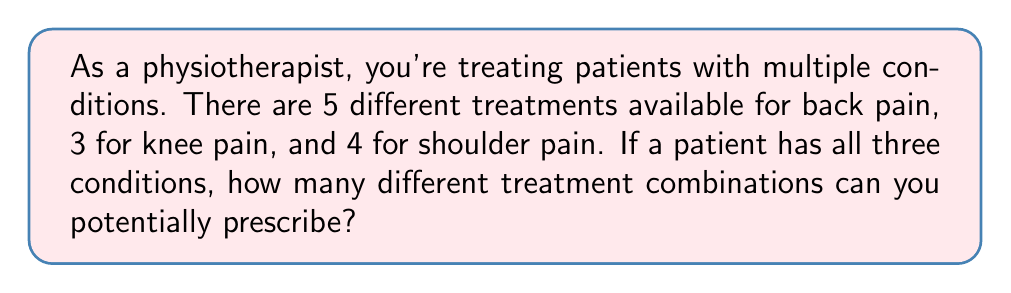Give your solution to this math problem. Let's approach this step-by-step:

1) We have three independent conditions, each with its own set of treatment options:
   - Back pain: 5 options
   - Knee pain: 3 options
   - Shoulder pain: 4 options

2) For each condition, we need to choose one treatment option. The choices for each condition are independent of the others.

3) This scenario is a perfect application of the multiplication principle in combinatorics. When we have independent events, and we want to know the total number of ways all events can occur, we multiply the number of ways each event can occur.

4) Mathematically, we can express this as:

   $$ \text{Total combinations} = \text{Back options} \times \text{Knee options} \times \text{Shoulder options} $$

5) Substituting the values:

   $$ \text{Total combinations} = 5 \times 3 \times 4 $$

6) Calculating:

   $$ \text{Total combinations} = 60 $$

Therefore, there are 60 different possible treatment combinations for a patient with all three conditions.
Answer: 60 